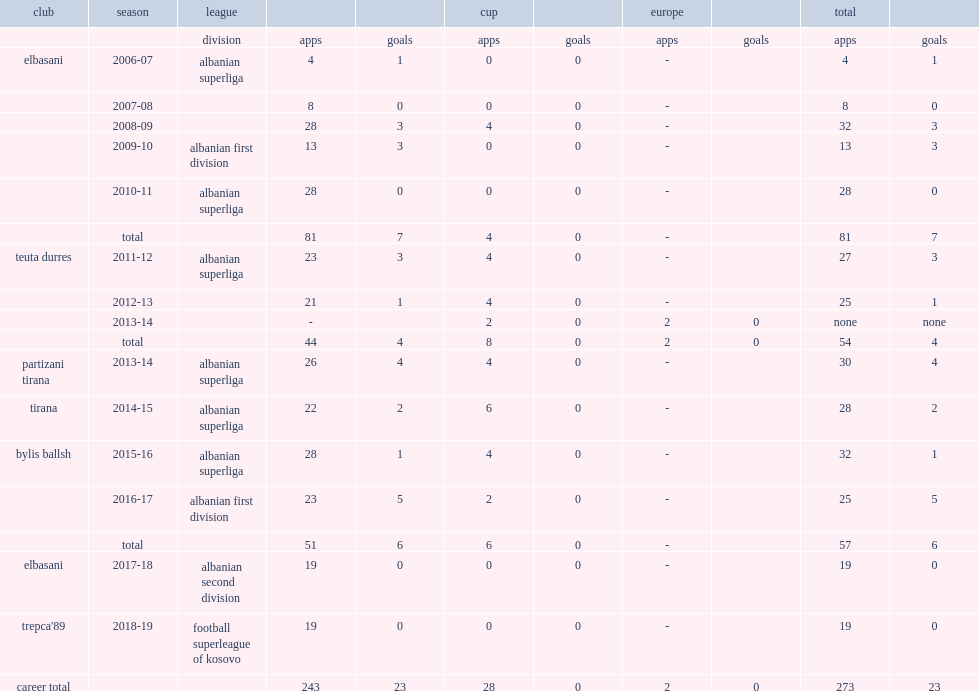After playing with partizani, which league did hyshmeri play with tirana in the 2014-15 season? Albanian superliga. 